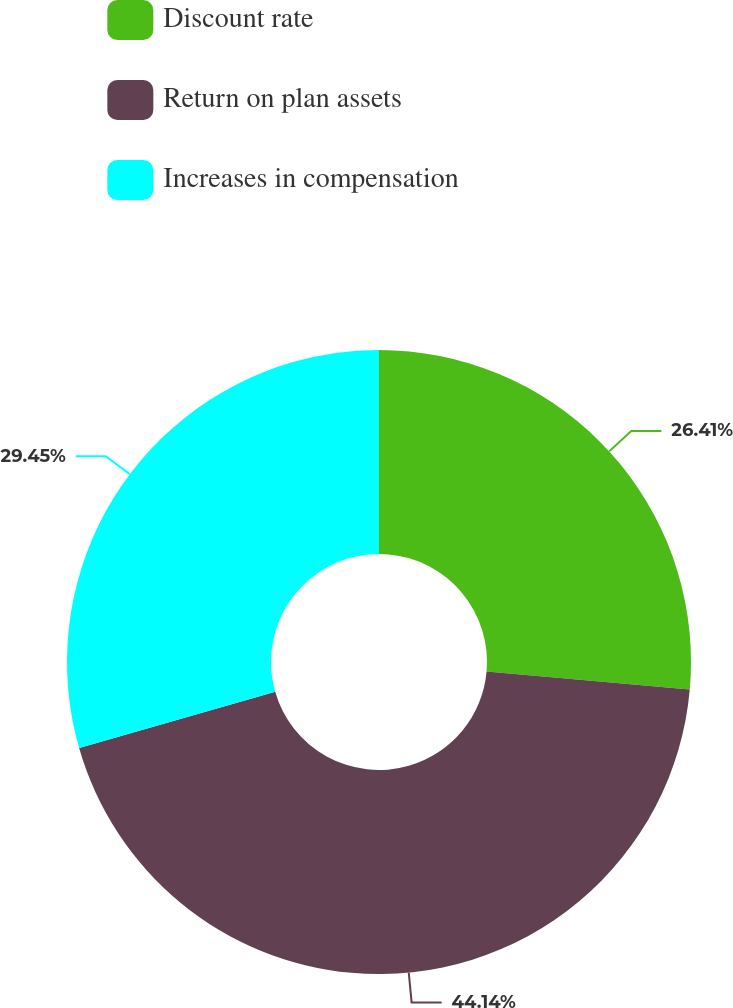Convert chart. <chart><loc_0><loc_0><loc_500><loc_500><pie_chart><fcel>Discount rate<fcel>Return on plan assets<fcel>Increases in compensation<nl><fcel>26.41%<fcel>44.14%<fcel>29.45%<nl></chart> 